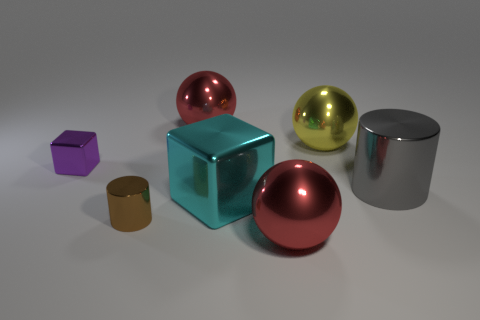There is a red ball to the right of the shiny sphere that is to the left of the large red shiny ball in front of the brown cylinder; what is it made of?
Provide a short and direct response. Metal. Does the large red object that is in front of the gray thing have the same shape as the big shiny thing that is on the left side of the cyan metal thing?
Your answer should be very brief. Yes. What is the color of the cube on the right side of the large red metallic object behind the tiny metallic cube?
Give a very brief answer. Cyan. What number of spheres are large shiny objects or large gray metallic things?
Offer a terse response. 3. How many big gray cylinders are left of the small shiny thing that is behind the block on the right side of the purple metallic cube?
Ensure brevity in your answer.  0. Are there any large spheres that have the same material as the tiny brown cylinder?
Your response must be concise. Yes. Is the material of the small cylinder the same as the purple object?
Give a very brief answer. Yes. How many red shiny spheres are to the left of the red sphere in front of the tiny metallic cylinder?
Offer a very short reply. 1. How many gray things are either large blocks or small blocks?
Give a very brief answer. 0. What shape is the small metallic object that is in front of the cyan thing to the right of the red shiny thing that is behind the cyan thing?
Provide a succinct answer. Cylinder. 